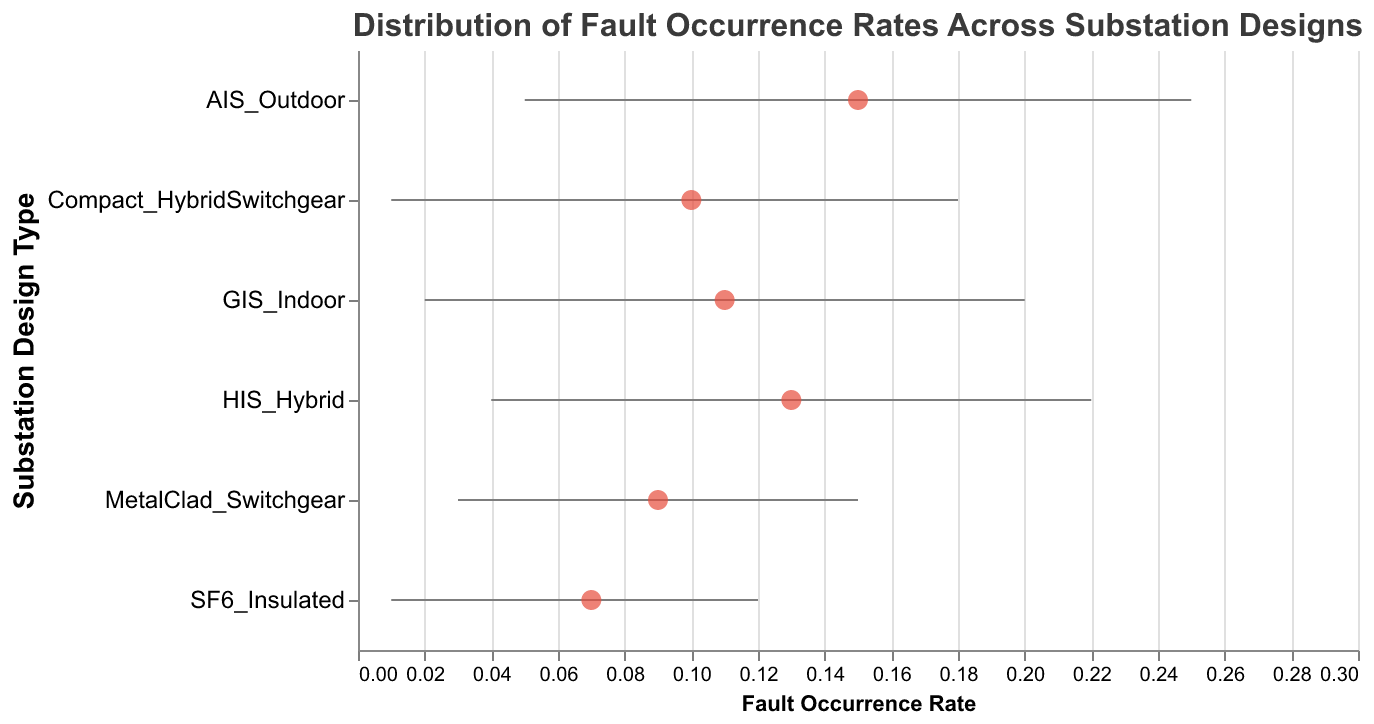What is the title of the graph? The title is found at the top of the graph and reads "Distribution of Fault Occurrence Rates Across Substation Designs".
Answer: Distribution of Fault Occurrence Rates Across Substation Designs Which substation design type has the highest maximum fault occurrence rate? By looking at the maximum values on the x-axis for each design type, AIS_Outdoor has the highest maximum fault occurrence rate at 0.25.
Answer: AIS_Outdoor Compare the average fault occurrence rate of GIS_Indoor and Compact_HybridSwitchgear. Which is higher and by how much? GIS_Indoor has an average fault occurrence rate of 0.11, and Compact_HybridSwitchgear has an average rate of 0.10. Subtracting these two gives 0.11 - 0.10 = 0.01, so GIS_Indoor is higher by 0.01.
Answer: GIS_Indoor by 0.01 What is the range of fault occurrence rates for MetalClad_Switchgear? The range is calculated by subtracting the minimum rate from the maximum rate: 0.15 - 0.03 = 0.12.
Answer: 0.12 Which substation design type has the smallest average fault occurrence rate? By comparing the average rates of all the design types, SF6_Insulated has the smallest average fault occurrence rate at 0.07.
Answer: SF6_Insulated How many substation designs have their minimum fault occurrence rate at 0.01? Both Compact_HybridSwitchgear and SF6_Insulated have a minimum fault occurrence rate of 0.01, thus there are 2 such substation designs.
Answer: 2 What is the difference in the maximum fault occurrence rates between HIS_Hybrid and GIS_Indoor? The maximum fault occurrence rate for HIS_Hybrid is 0.22 and for GIS_Indoor is 0.20. The difference is 0.22 - 0.20 = 0.02.
Answer: 0.02 For which substation design is the average fault occurrence rate exactly in the middle of its minimum and maximum rates? For MetalClad_Switchgear, the average rate of 0.09 is exactly in the middle because (0.03 + 0.15) / 2 = 0.09.
Answer: MetalClad_Switchgear Which substation design type shows the largest range of fault occurrence rates? By comparing the ranges (max - min) for each design type, AIS_Outdoor has the largest range of 0.25 - 0.05 = 0.20.
Answer: AIS_Outdoor 